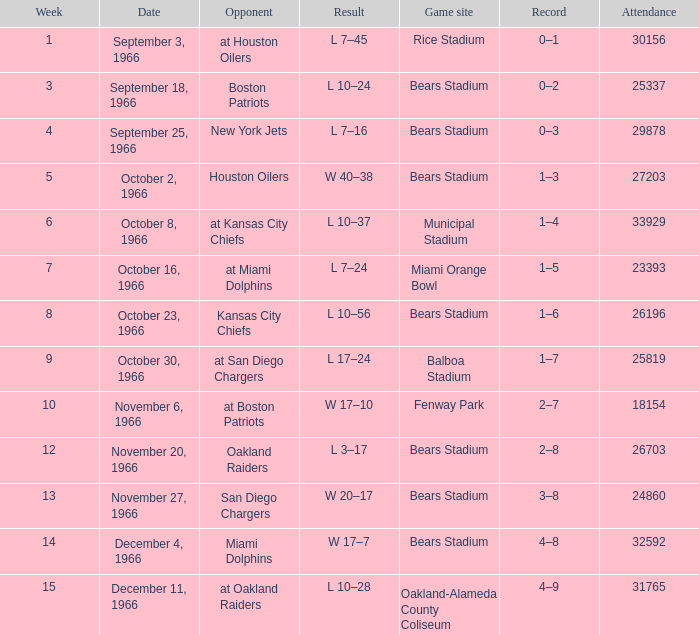How many listings are there for the 13th week? 1.0. 